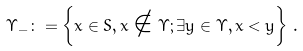Convert formula to latex. <formula><loc_0><loc_0><loc_500><loc_500>\Upsilon _ { - } \colon = \left \{ x \in S , x \notin \Upsilon ; \exists y \in \Upsilon , x < y \right \} \, .</formula> 